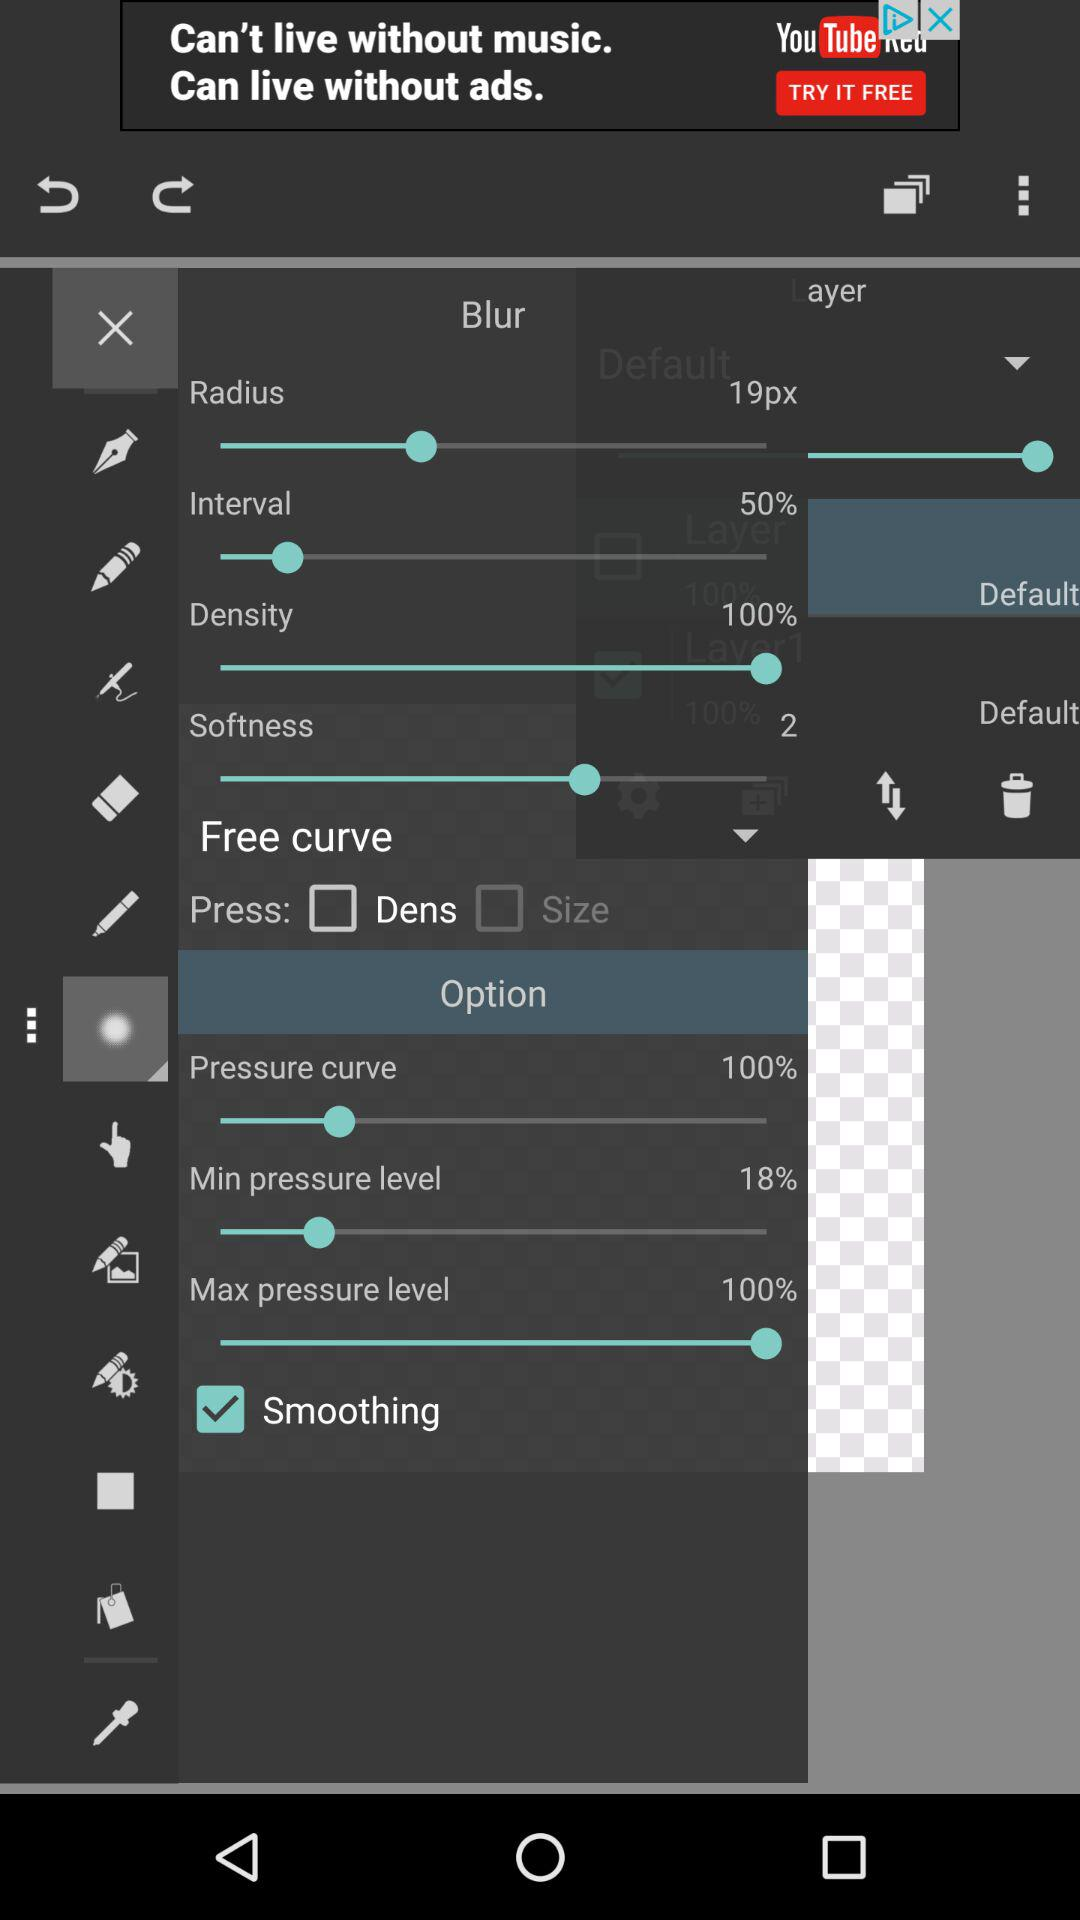What is the status of "Smoothing"? The status is "on". 